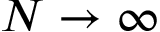<formula> <loc_0><loc_0><loc_500><loc_500>N \to \infty</formula> 